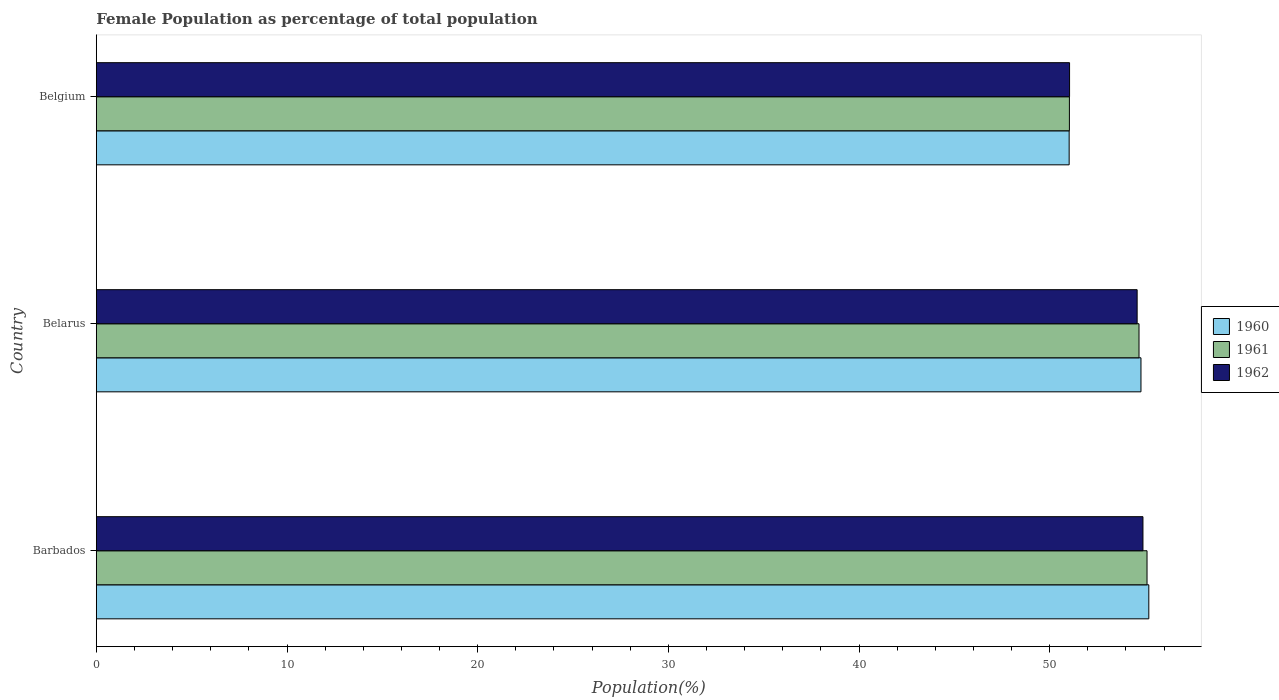How many different coloured bars are there?
Provide a short and direct response. 3. Are the number of bars on each tick of the Y-axis equal?
Provide a succinct answer. Yes. What is the label of the 2nd group of bars from the top?
Ensure brevity in your answer.  Belarus. In how many cases, is the number of bars for a given country not equal to the number of legend labels?
Provide a succinct answer. 0. What is the female population in in 1960 in Barbados?
Offer a terse response. 55.2. Across all countries, what is the maximum female population in in 1962?
Offer a terse response. 54.89. Across all countries, what is the minimum female population in in 1962?
Keep it short and to the point. 51.04. In which country was the female population in in 1961 maximum?
Your response must be concise. Barbados. What is the total female population in in 1962 in the graph?
Your answer should be very brief. 160.52. What is the difference between the female population in in 1962 in Belarus and that in Belgium?
Your answer should be very brief. 3.54. What is the difference between the female population in in 1962 in Barbados and the female population in in 1961 in Belarus?
Your answer should be very brief. 0.21. What is the average female population in in 1962 per country?
Your answer should be compact. 53.51. What is the difference between the female population in in 1961 and female population in in 1960 in Belarus?
Offer a terse response. -0.1. In how many countries, is the female population in in 1961 greater than 48 %?
Keep it short and to the point. 3. What is the ratio of the female population in in 1961 in Belarus to that in Belgium?
Your answer should be very brief. 1.07. Is the female population in in 1960 in Barbados less than that in Belgium?
Your answer should be compact. No. Is the difference between the female population in in 1961 in Barbados and Belarus greater than the difference between the female population in in 1960 in Barbados and Belarus?
Ensure brevity in your answer.  Yes. What is the difference between the highest and the second highest female population in in 1960?
Make the answer very short. 0.41. What is the difference between the highest and the lowest female population in in 1961?
Your answer should be very brief. 4.07. What does the 3rd bar from the top in Barbados represents?
Offer a terse response. 1960. Are all the bars in the graph horizontal?
Provide a succinct answer. Yes. What is the difference between two consecutive major ticks on the X-axis?
Your answer should be very brief. 10. Where does the legend appear in the graph?
Offer a very short reply. Center right. What is the title of the graph?
Your answer should be very brief. Female Population as percentage of total population. Does "2002" appear as one of the legend labels in the graph?
Keep it short and to the point. No. What is the label or title of the X-axis?
Make the answer very short. Population(%). What is the label or title of the Y-axis?
Keep it short and to the point. Country. What is the Population(%) of 1960 in Barbados?
Ensure brevity in your answer.  55.2. What is the Population(%) in 1961 in Barbados?
Your response must be concise. 55.11. What is the Population(%) in 1962 in Barbados?
Your answer should be very brief. 54.89. What is the Population(%) of 1960 in Belarus?
Your answer should be compact. 54.79. What is the Population(%) in 1961 in Belarus?
Provide a short and direct response. 54.69. What is the Population(%) in 1962 in Belarus?
Provide a short and direct response. 54.59. What is the Population(%) in 1960 in Belgium?
Ensure brevity in your answer.  51.02. What is the Population(%) in 1961 in Belgium?
Provide a succinct answer. 51.03. What is the Population(%) in 1962 in Belgium?
Ensure brevity in your answer.  51.04. Across all countries, what is the maximum Population(%) in 1960?
Make the answer very short. 55.2. Across all countries, what is the maximum Population(%) of 1961?
Your response must be concise. 55.11. Across all countries, what is the maximum Population(%) of 1962?
Ensure brevity in your answer.  54.89. Across all countries, what is the minimum Population(%) of 1960?
Your response must be concise. 51.02. Across all countries, what is the minimum Population(%) in 1961?
Make the answer very short. 51.03. Across all countries, what is the minimum Population(%) of 1962?
Ensure brevity in your answer.  51.04. What is the total Population(%) in 1960 in the graph?
Offer a very short reply. 161.01. What is the total Population(%) of 1961 in the graph?
Your answer should be compact. 160.83. What is the total Population(%) in 1962 in the graph?
Your response must be concise. 160.52. What is the difference between the Population(%) of 1960 in Barbados and that in Belarus?
Your answer should be compact. 0.41. What is the difference between the Population(%) in 1961 in Barbados and that in Belarus?
Provide a succinct answer. 0.42. What is the difference between the Population(%) in 1962 in Barbados and that in Belarus?
Provide a short and direct response. 0.3. What is the difference between the Population(%) in 1960 in Barbados and that in Belgium?
Offer a very short reply. 4.18. What is the difference between the Population(%) in 1961 in Barbados and that in Belgium?
Provide a short and direct response. 4.07. What is the difference between the Population(%) of 1962 in Barbados and that in Belgium?
Provide a succinct answer. 3.85. What is the difference between the Population(%) in 1960 in Belarus and that in Belgium?
Make the answer very short. 3.77. What is the difference between the Population(%) in 1961 in Belarus and that in Belgium?
Your answer should be compact. 3.65. What is the difference between the Population(%) of 1962 in Belarus and that in Belgium?
Ensure brevity in your answer.  3.54. What is the difference between the Population(%) in 1960 in Barbados and the Population(%) in 1961 in Belarus?
Give a very brief answer. 0.51. What is the difference between the Population(%) in 1960 in Barbados and the Population(%) in 1962 in Belarus?
Provide a succinct answer. 0.61. What is the difference between the Population(%) in 1961 in Barbados and the Population(%) in 1962 in Belarus?
Offer a terse response. 0.52. What is the difference between the Population(%) of 1960 in Barbados and the Population(%) of 1961 in Belgium?
Make the answer very short. 4.16. What is the difference between the Population(%) in 1960 in Barbados and the Population(%) in 1962 in Belgium?
Give a very brief answer. 4.16. What is the difference between the Population(%) of 1961 in Barbados and the Population(%) of 1962 in Belgium?
Your answer should be compact. 4.06. What is the difference between the Population(%) of 1960 in Belarus and the Population(%) of 1961 in Belgium?
Provide a succinct answer. 3.75. What is the difference between the Population(%) in 1960 in Belarus and the Population(%) in 1962 in Belgium?
Provide a succinct answer. 3.75. What is the difference between the Population(%) of 1961 in Belarus and the Population(%) of 1962 in Belgium?
Make the answer very short. 3.64. What is the average Population(%) in 1960 per country?
Provide a succinct answer. 53.67. What is the average Population(%) of 1961 per country?
Your answer should be very brief. 53.61. What is the average Population(%) of 1962 per country?
Provide a short and direct response. 53.51. What is the difference between the Population(%) in 1960 and Population(%) in 1961 in Barbados?
Your response must be concise. 0.09. What is the difference between the Population(%) of 1960 and Population(%) of 1962 in Barbados?
Your answer should be very brief. 0.31. What is the difference between the Population(%) of 1961 and Population(%) of 1962 in Barbados?
Ensure brevity in your answer.  0.21. What is the difference between the Population(%) of 1960 and Population(%) of 1961 in Belarus?
Your answer should be very brief. 0.1. What is the difference between the Population(%) of 1960 and Population(%) of 1962 in Belarus?
Make the answer very short. 0.2. What is the difference between the Population(%) of 1961 and Population(%) of 1962 in Belarus?
Make the answer very short. 0.1. What is the difference between the Population(%) of 1960 and Population(%) of 1961 in Belgium?
Give a very brief answer. -0.01. What is the difference between the Population(%) of 1960 and Population(%) of 1962 in Belgium?
Make the answer very short. -0.02. What is the difference between the Population(%) in 1961 and Population(%) in 1962 in Belgium?
Provide a succinct answer. -0.01. What is the ratio of the Population(%) of 1960 in Barbados to that in Belarus?
Ensure brevity in your answer.  1.01. What is the ratio of the Population(%) in 1961 in Barbados to that in Belarus?
Offer a very short reply. 1.01. What is the ratio of the Population(%) of 1962 in Barbados to that in Belarus?
Give a very brief answer. 1.01. What is the ratio of the Population(%) of 1960 in Barbados to that in Belgium?
Ensure brevity in your answer.  1.08. What is the ratio of the Population(%) of 1961 in Barbados to that in Belgium?
Offer a terse response. 1.08. What is the ratio of the Population(%) in 1962 in Barbados to that in Belgium?
Ensure brevity in your answer.  1.08. What is the ratio of the Population(%) of 1960 in Belarus to that in Belgium?
Provide a succinct answer. 1.07. What is the ratio of the Population(%) in 1961 in Belarus to that in Belgium?
Your answer should be very brief. 1.07. What is the ratio of the Population(%) in 1962 in Belarus to that in Belgium?
Ensure brevity in your answer.  1.07. What is the difference between the highest and the second highest Population(%) of 1960?
Make the answer very short. 0.41. What is the difference between the highest and the second highest Population(%) in 1961?
Offer a terse response. 0.42. What is the difference between the highest and the second highest Population(%) in 1962?
Provide a succinct answer. 0.3. What is the difference between the highest and the lowest Population(%) in 1960?
Your response must be concise. 4.18. What is the difference between the highest and the lowest Population(%) of 1961?
Keep it short and to the point. 4.07. What is the difference between the highest and the lowest Population(%) in 1962?
Your response must be concise. 3.85. 